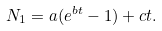<formula> <loc_0><loc_0><loc_500><loc_500>N _ { 1 } = a ( e ^ { b t } - 1 ) + c t .</formula> 